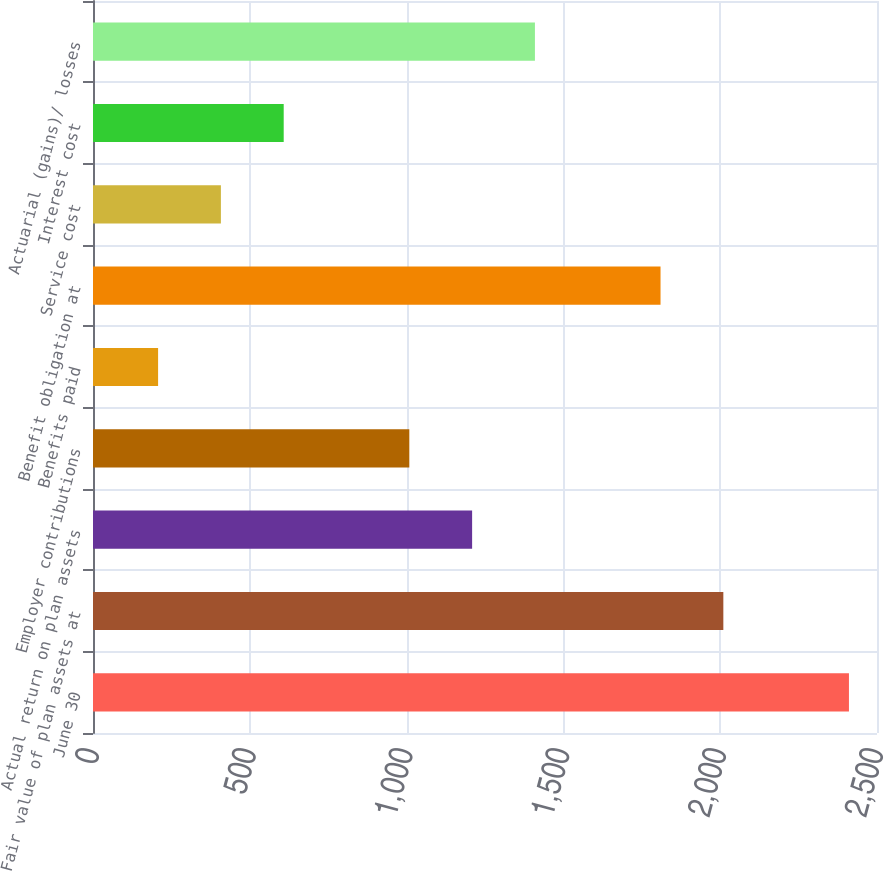Convert chart to OTSL. <chart><loc_0><loc_0><loc_500><loc_500><bar_chart><fcel>June 30<fcel>Fair value of plan assets at<fcel>Actual return on plan assets<fcel>Employer contributions<fcel>Benefits paid<fcel>Benefit obligation at<fcel>Service cost<fcel>Interest cost<fcel>Actuarial (gains)/ losses<nl><fcel>2410.54<fcel>2010<fcel>1208.92<fcel>1008.65<fcel>207.57<fcel>1809.73<fcel>407.84<fcel>608.11<fcel>1409.19<nl></chart> 